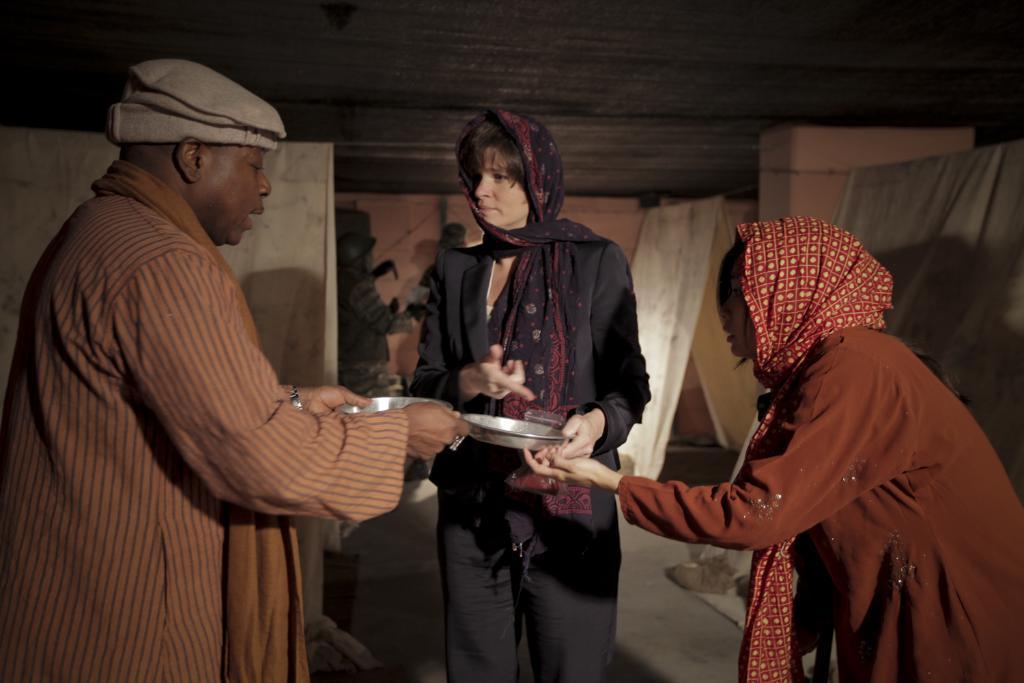Please provide a concise description of this image. In this picture we can see a man and two women standing on the ground where two people are holding plates with their hands and in the background we can see wall. 